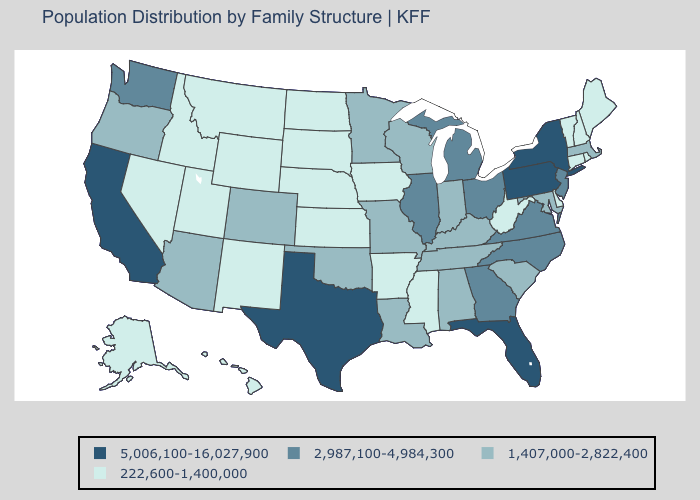Does Missouri have the highest value in the MidWest?
Concise answer only. No. How many symbols are there in the legend?
Short answer required. 4. Among the states that border Idaho , which have the lowest value?
Write a very short answer. Montana, Nevada, Utah, Wyoming. Name the states that have a value in the range 2,987,100-4,984,300?
Give a very brief answer. Georgia, Illinois, Michigan, New Jersey, North Carolina, Ohio, Virginia, Washington. Which states have the lowest value in the USA?
Give a very brief answer. Alaska, Arkansas, Connecticut, Delaware, Hawaii, Idaho, Iowa, Kansas, Maine, Mississippi, Montana, Nebraska, Nevada, New Hampshire, New Mexico, North Dakota, Rhode Island, South Dakota, Utah, Vermont, West Virginia, Wyoming. Among the states that border Delaware , does Pennsylvania have the lowest value?
Be succinct. No. Name the states that have a value in the range 2,987,100-4,984,300?
Be succinct. Georgia, Illinois, Michigan, New Jersey, North Carolina, Ohio, Virginia, Washington. What is the value of Nevada?
Write a very short answer. 222,600-1,400,000. Name the states that have a value in the range 2,987,100-4,984,300?
Be succinct. Georgia, Illinois, Michigan, New Jersey, North Carolina, Ohio, Virginia, Washington. Does Texas have the highest value in the USA?
Answer briefly. Yes. Does Wyoming have a higher value than Maryland?
Quick response, please. No. Which states have the lowest value in the Northeast?
Write a very short answer. Connecticut, Maine, New Hampshire, Rhode Island, Vermont. Does Maryland have the highest value in the South?
Answer briefly. No. What is the value of Alabama?
Write a very short answer. 1,407,000-2,822,400. Name the states that have a value in the range 5,006,100-16,027,900?
Answer briefly. California, Florida, New York, Pennsylvania, Texas. 